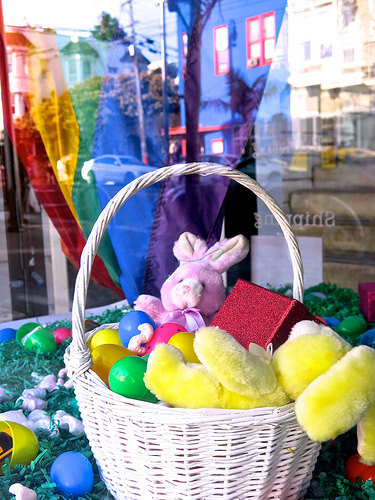<image>
Can you confirm if the bunny is behind the egg? Yes. From this viewpoint, the bunny is positioned behind the egg, with the egg partially or fully occluding the bunny. 